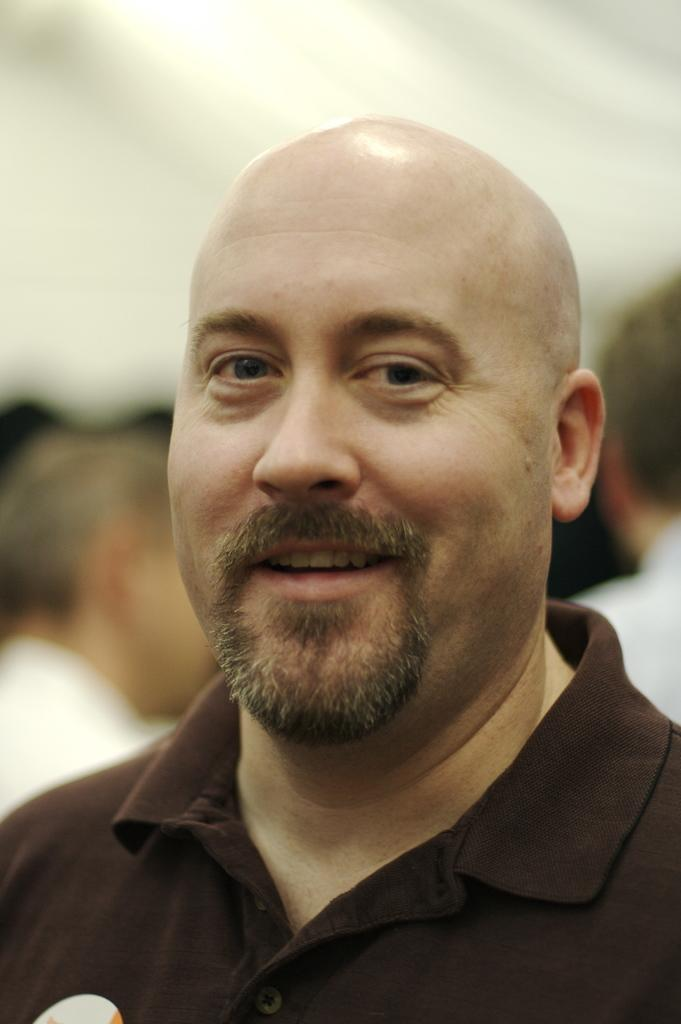Who is present in the image? There is a person in the image. What is the person doing? The person is smiling. Are there any other people visible in the image? Yes, there are other people behind the person. What can be seen on the roof in the image? There is a light on the roof in the image. How many goldfish are swimming in the territory behind the person in the image? There are no goldfish or territory visible in the image. 